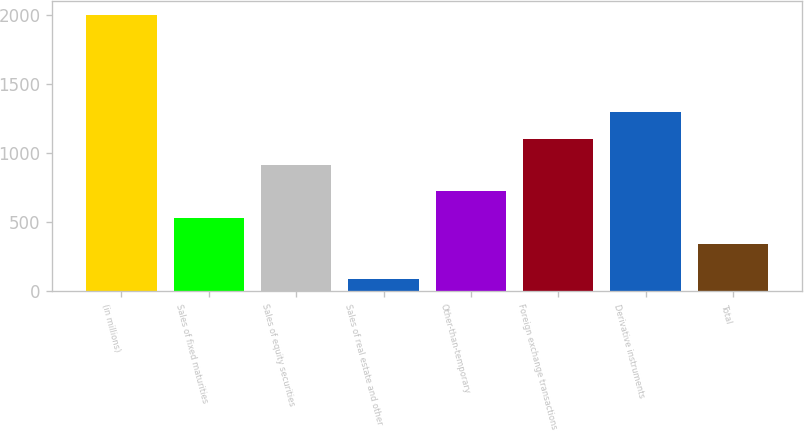<chart> <loc_0><loc_0><loc_500><loc_500><bar_chart><fcel>(in millions)<fcel>Sales of fixed maturities<fcel>Sales of equity securities<fcel>Sales of real estate and other<fcel>Other-than-temporary<fcel>Foreign exchange transactions<fcel>Derivative instruments<fcel>Total<nl><fcel>2005<fcel>532.7<fcel>916.1<fcel>88<fcel>724.4<fcel>1107.8<fcel>1299.5<fcel>341<nl></chart> 